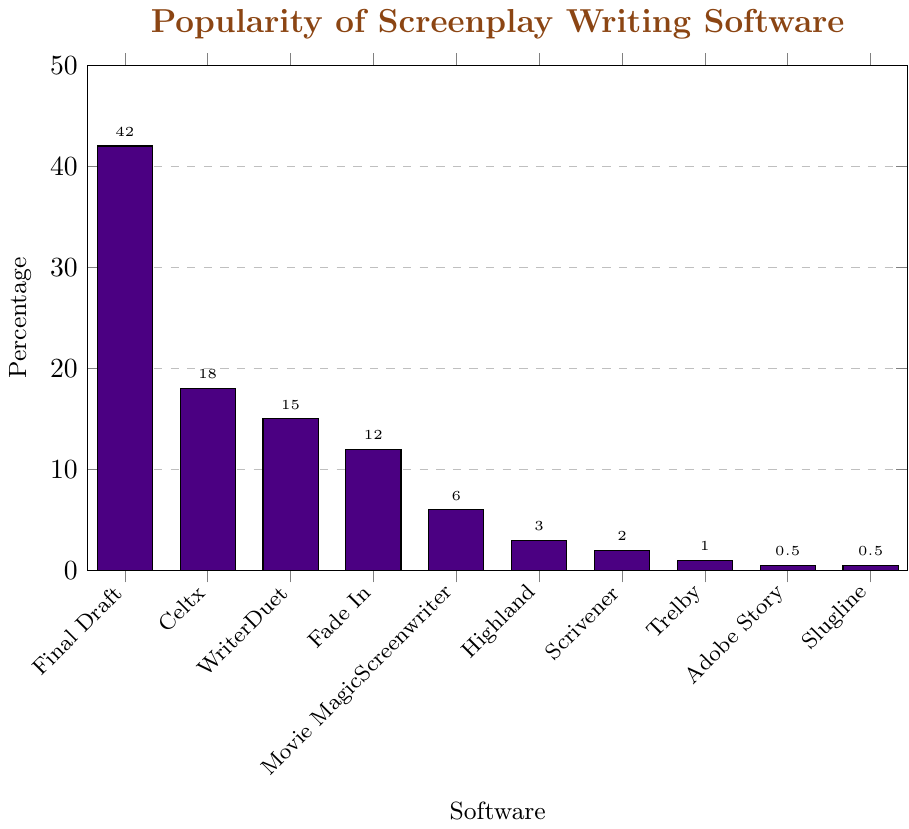Which software is the most popular among professional screenwriters? The figure shows the percentage of screenwriters using each software, with Final Draft having the highest bar.
Answer: Final Draft Which two software have the least popularity among professional screenwriters, and are their usage percentages the same? The bars representing Adobe Story and Slugline are the shortest, each with a value of 0.5%.
Answer: Adobe Story, Slugline What is the combined percentage of screenwriters using Celtx and WriterDuet? According to the figure, Celtx has a percentage of 18%, and WriterDuet has 15%. Adding these gives 18 + 15 = 33%.
Answer: 33% Which software has a larger percentage of users: Fade In or Movie Magic Screenwriter? The bar for Fade In is higher than the bar for Movie Magic Screenwriter, with 12% and 6% respectively.
Answer: Fade In What is the difference in percentage between the most popular software and the least popular software? The most popular software, Final Draft, has 42%, and the least popular software, Adobe Story and Slugline, each have 0.5%. The difference is 42 - 0.5 = 41.5%.
Answer: 41.5% Is the percentage of screenwriters using Scrivener greater than, less than, or equal to those using Highland? The bar for Highland indicates 3%, while Scrivener has 2%. Thus, Scrivener has a lower percentage than Highland.
Answer: Less than What is the average percentage of screenwriters using the top three software? The top three software are Final Draft (42%), Celtx (18%), and WriterDuet (15%). The average is (42 + 18 + 15) / 3 = 75 / 3 = 25%.
Answer: 25% How many software options have a percentage of users below 5%? According to the figure, Movie Magic Screenwriter (6%), Highland (3%), Scrivener (2%), Trelby (1%), Adobe Story (0.5%), and Slugline (0.5%) are below 5%. This counts up to six software options.
Answer: 6 What is the closest percentage value to 10% among the software presented? The closest percentage to 10% in the figure is 12% for Fade In.
Answer: 12% 